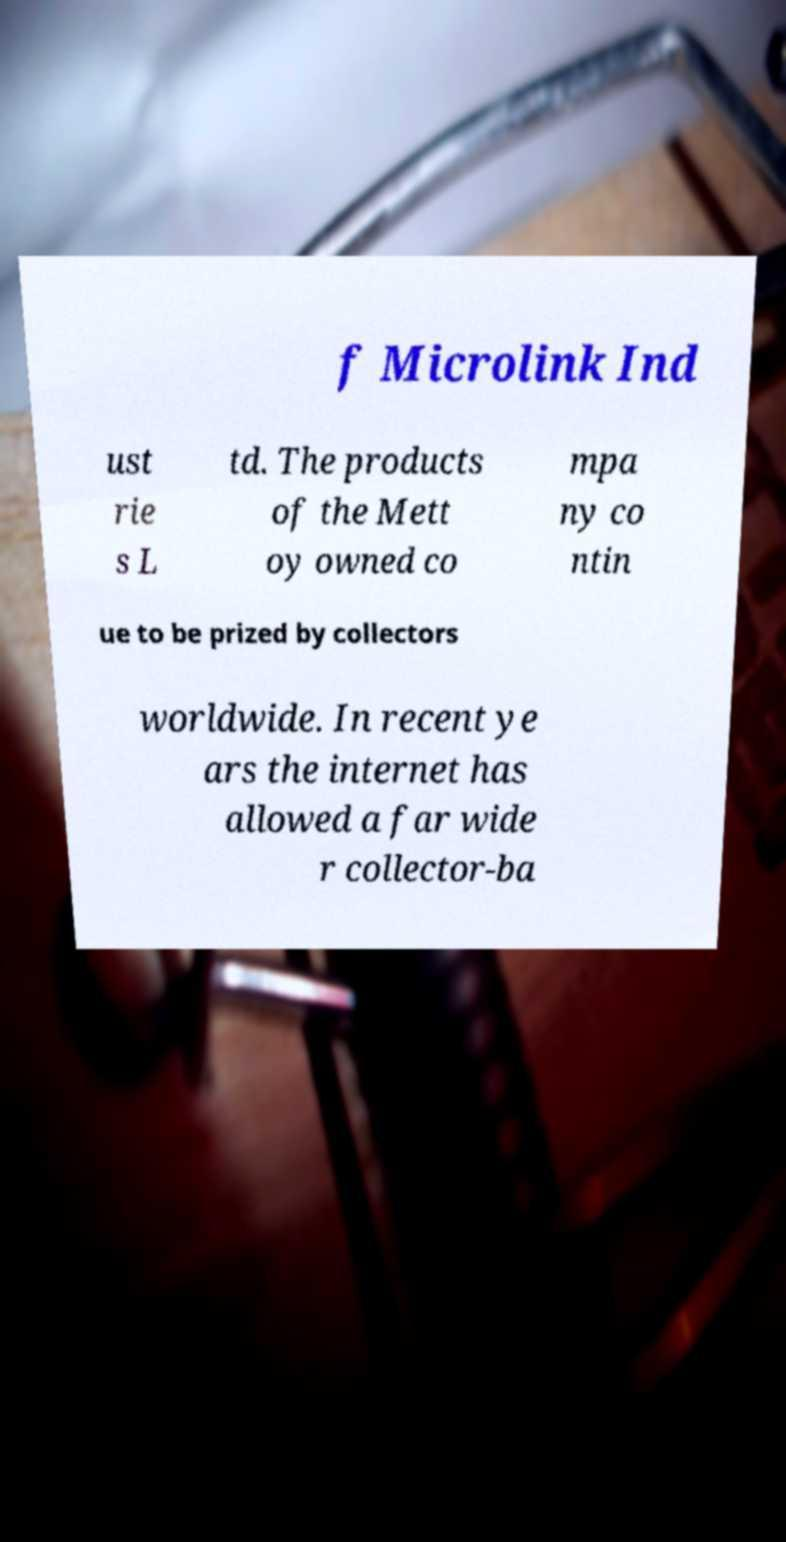Could you extract and type out the text from this image? f Microlink Ind ust rie s L td. The products of the Mett oy owned co mpa ny co ntin ue to be prized by collectors worldwide. In recent ye ars the internet has allowed a far wide r collector-ba 